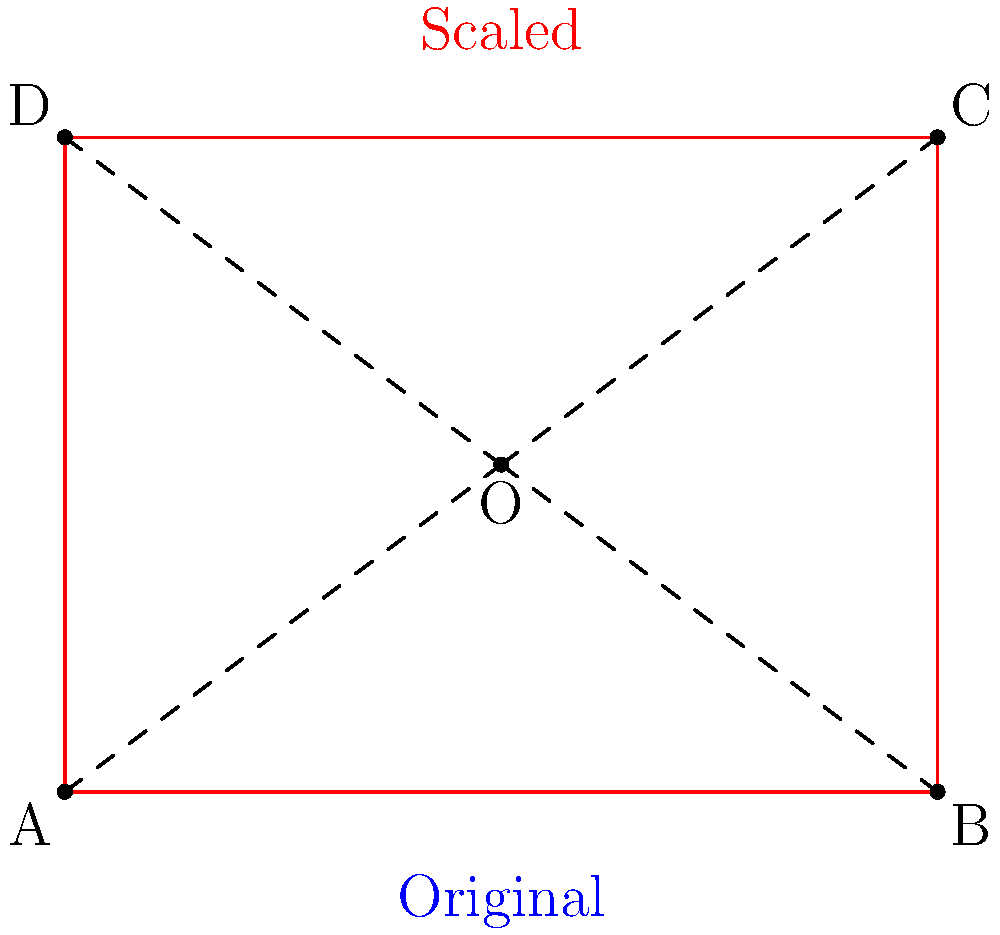A rectangular bulletin board in the school hallway measures 4 feet wide and 3 feet tall. To make it more noticeable, you decide to scale it up from its center point. If the scaling factor is 2, what will be the dimensions of the new, larger bulletin board? Let's approach this step-by-step:

1) The original rectangle has dimensions 4 feet wide and 3 feet tall.

2) The scaling factor is 2, which means each point of the rectangle will move away from the center point by a factor of 2.

3) When we scale a figure from a center point, the distance of each point from the center is multiplied by the scaling factor.

4) This means that the dimensions of the figure will also be multiplied by the scaling factor.

5) New width = Original width × Scaling factor
   $4 \times 2 = 8$ feet

6) New height = Original height × Scaling factor
   $3 \times 2 = 6$ feet

Therefore, the new, larger bulletin board will measure 8 feet wide and 6 feet tall.
Answer: 8 feet wide, 6 feet tall 